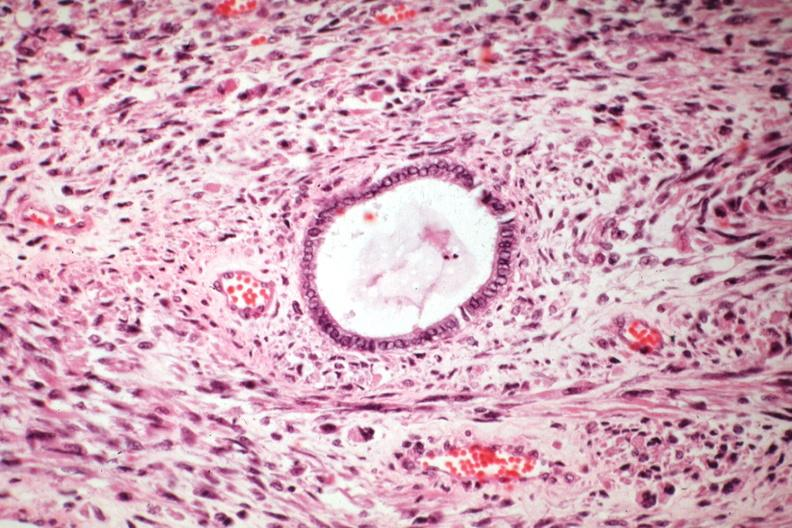what is present?
Answer the question using a single word or phrase. Mixed mesodermal tumor 